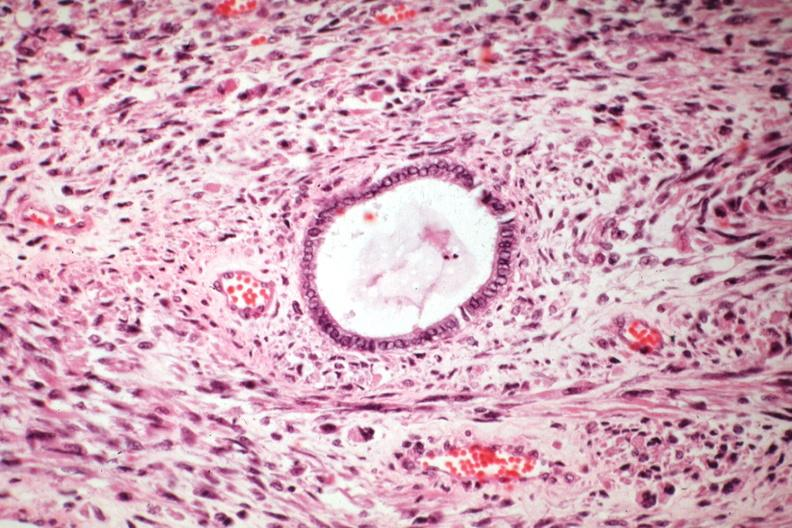what is present?
Answer the question using a single word or phrase. Mixed mesodermal tumor 